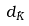<formula> <loc_0><loc_0><loc_500><loc_500>d _ { \hat { K } }</formula> 